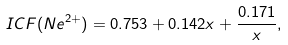<formula> <loc_0><loc_0><loc_500><loc_500>I C F ( N e ^ { 2 + } ) = 0 . 7 5 3 + 0 . 1 4 2 x + \frac { 0 . 1 7 1 } { x } ,</formula> 